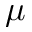Convert formula to latex. <formula><loc_0><loc_0><loc_500><loc_500>\mu</formula> 